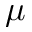Convert formula to latex. <formula><loc_0><loc_0><loc_500><loc_500>\mu</formula> 